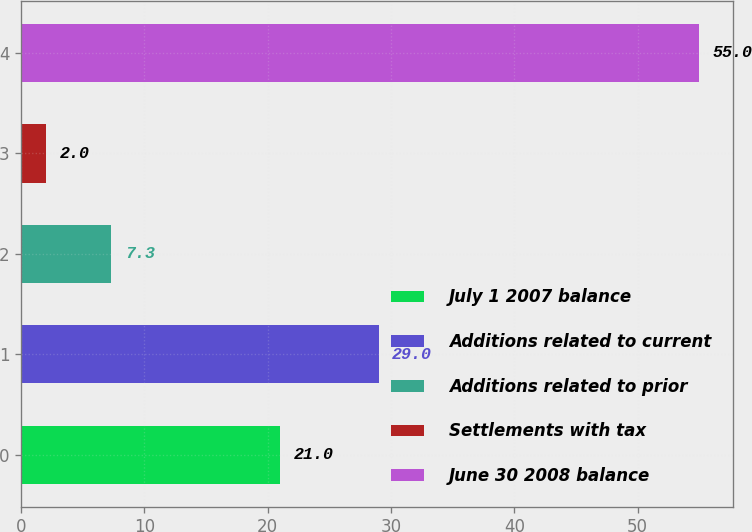Convert chart to OTSL. <chart><loc_0><loc_0><loc_500><loc_500><bar_chart><fcel>July 1 2007 balance<fcel>Additions related to current<fcel>Additions related to prior<fcel>Settlements with tax<fcel>June 30 2008 balance<nl><fcel>21<fcel>29<fcel>7.3<fcel>2<fcel>55<nl></chart> 